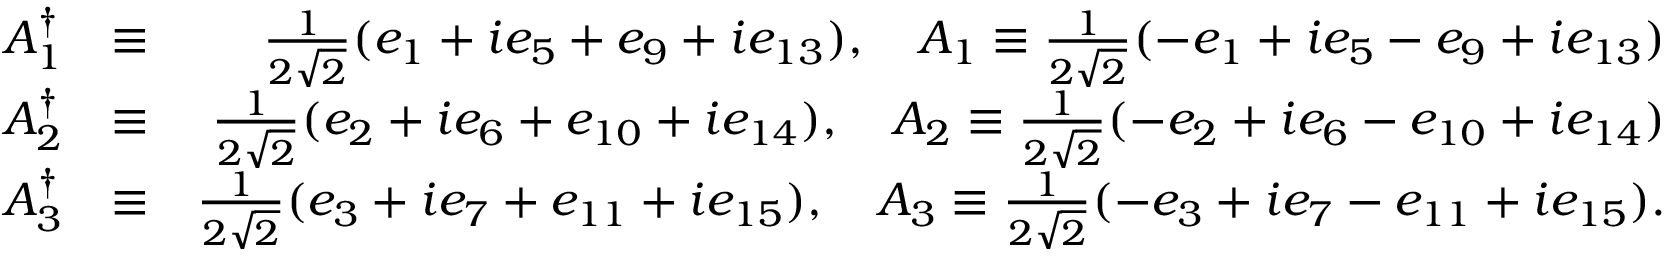<formula> <loc_0><loc_0><loc_500><loc_500>\begin{array} { r l r } { A _ { 1 } ^ { \dagger } } & { \equiv } & { \frac { 1 } { 2 \sqrt { 2 } } ( e _ { 1 } + i e _ { 5 } + e _ { 9 } + i e _ { 1 3 } ) , \quad A _ { 1 } \equiv \frac { 1 } { 2 \sqrt { 2 } } ( - e _ { 1 } + i e _ { 5 } - e _ { 9 } + i e _ { 1 3 } ) } \\ { A _ { 2 } ^ { \dagger } } & { \equiv } & { \frac { 1 } { 2 \sqrt { 2 } } ( e _ { 2 } + i e _ { 6 } + e _ { 1 0 } + i e _ { 1 4 } ) , \quad A _ { 2 } \equiv \frac { 1 } { 2 \sqrt { 2 } } ( - e _ { 2 } + i e _ { 6 } - e _ { 1 0 } + i e _ { 1 4 } ) } \\ { A _ { 3 } ^ { \dagger } } & { \equiv } & { \frac { 1 } { 2 \sqrt { 2 } } ( e _ { 3 } + i e _ { 7 } + e _ { 1 1 } + i e _ { 1 5 } ) , \quad A _ { 3 } \equiv \frac { 1 } { 2 \sqrt { 2 } } ( - e _ { 3 } + i e _ { 7 } - e _ { 1 1 } + i e _ { 1 5 } ) . } \end{array}</formula> 